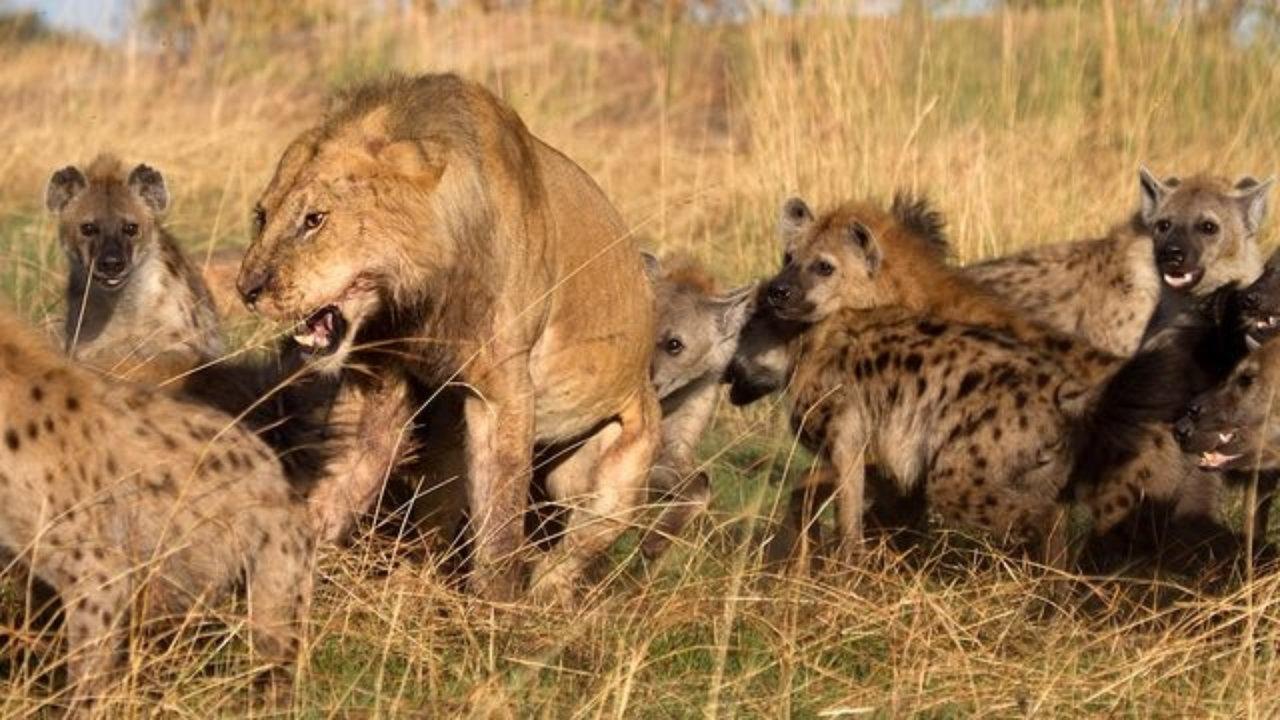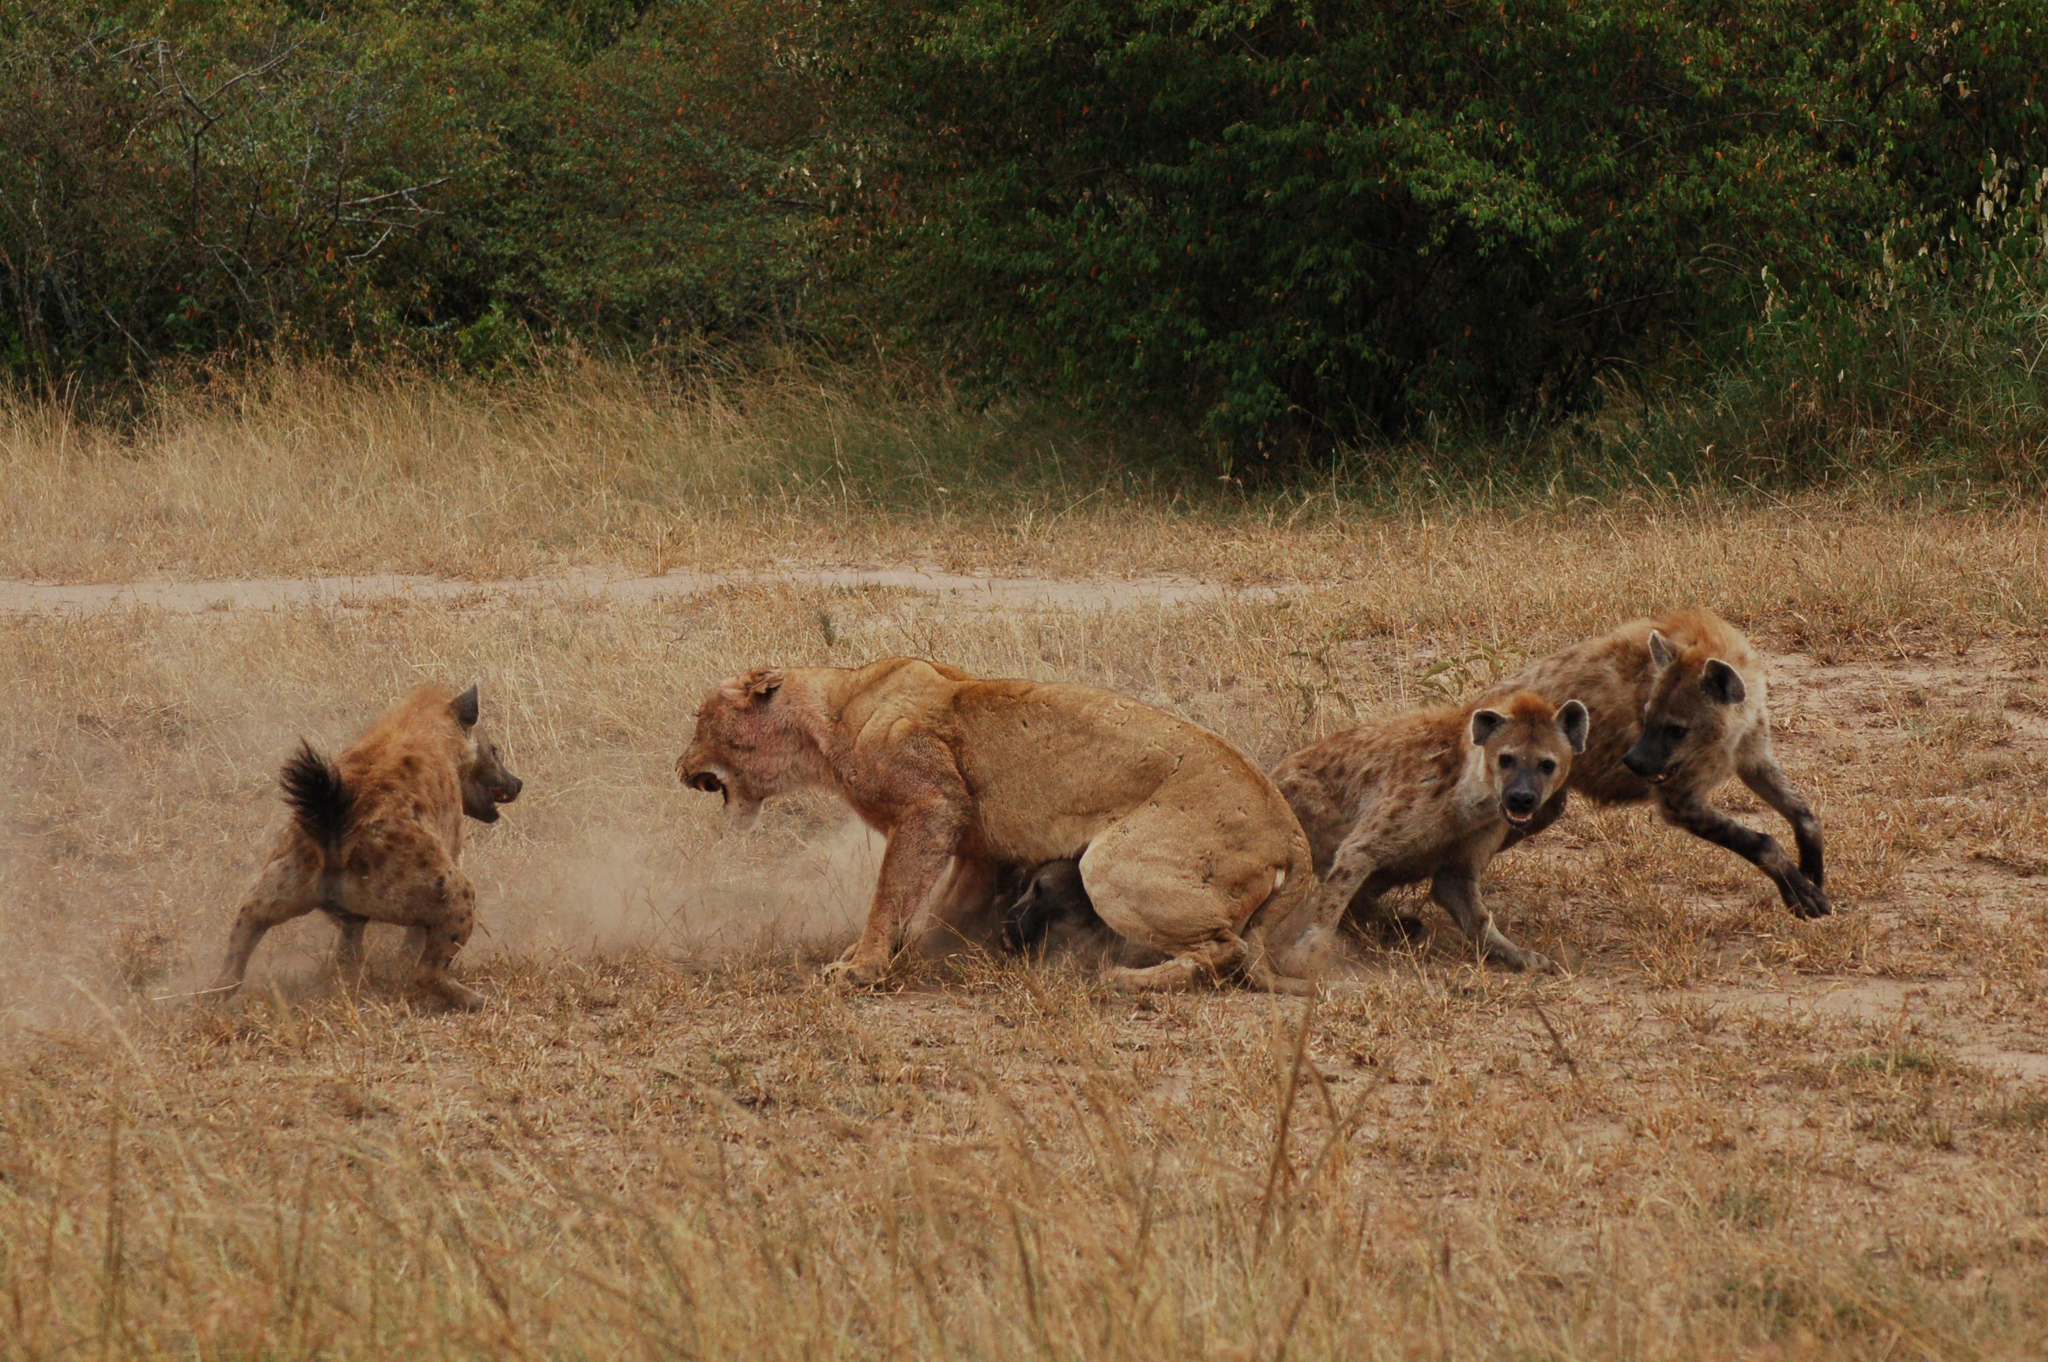The first image is the image on the left, the second image is the image on the right. For the images displayed, is the sentence "A male lion is being attacked by hyenas." factually correct? Answer yes or no. Yes. The first image is the image on the left, the second image is the image on the right. Assess this claim about the two images: "The right image contains no more than three hyenas.". Correct or not? Answer yes or no. Yes. 